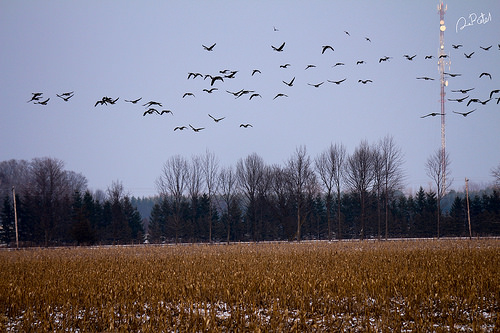<image>
Is the bird in front of the sky? Yes. The bird is positioned in front of the sky, appearing closer to the camera viewpoint. 